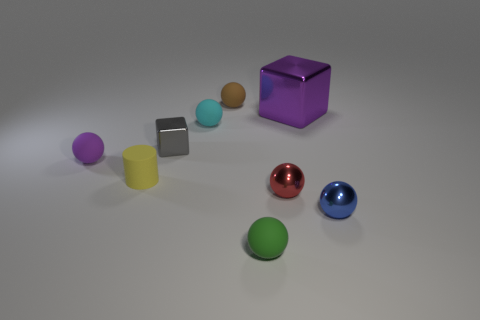Is there anything else that is the same size as the purple block?
Ensure brevity in your answer.  No. The cyan object that is right of the tiny cube has what shape?
Make the answer very short. Sphere. Is there any other thing that has the same material as the small red object?
Keep it short and to the point. Yes. Is the number of balls behind the gray shiny cube greater than the number of metal things?
Offer a terse response. No. What number of matte things are in front of the small metallic ball that is in front of the metallic ball to the left of the large purple thing?
Offer a terse response. 1. Does the ball that is to the left of the small cyan matte thing have the same size as the block that is on the left side of the green ball?
Offer a very short reply. Yes. What is the material of the purple thing that is right of the purple thing in front of the small block?
Provide a short and direct response. Metal. What number of objects are small matte things that are behind the tiny rubber cylinder or brown spheres?
Offer a terse response. 3. Are there the same number of small red objects that are to the left of the small purple matte sphere and small red metal objects that are to the left of the small red thing?
Provide a succinct answer. Yes. There is a ball left of the small shiny thing on the left side of the small rubber sphere in front of the red metallic thing; what is it made of?
Your answer should be very brief. Rubber. 